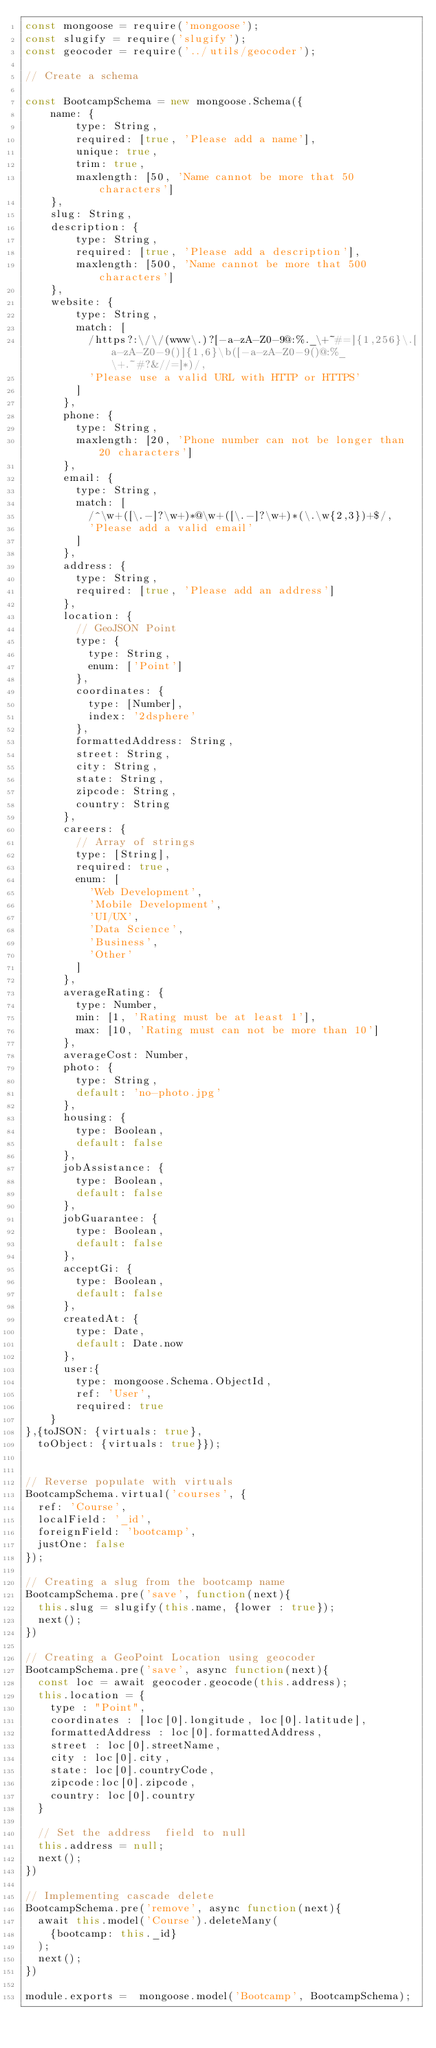<code> <loc_0><loc_0><loc_500><loc_500><_JavaScript_>const mongoose = require('mongoose');
const slugify = require('slugify');
const geocoder = require('../utils/geocoder');

// Create a schema

const BootcampSchema = new mongoose.Schema({
    name: {
        type: String,
        required: [true, 'Please add a name'],
        unique: true,
        trim: true,
        maxlength: [50, 'Name cannot be more that 50 characters']
    },
    slug: String,
    description: {
        type: String,
        required: [true, 'Please add a description'],
        maxlength: [500, 'Name cannot be more that 500 characters']
    },
    website: {
        type: String,
        match: [
          /https?:\/\/(www\.)?[-a-zA-Z0-9@:%._\+~#=]{1,256}\.[a-zA-Z0-9()]{1,6}\b([-a-zA-Z0-9()@:%_\+.~#?&//=]*)/,
          'Please use a valid URL with HTTP or HTTPS'
        ]
      },
      phone: {
        type: String,
        maxlength: [20, 'Phone number can not be longer than 20 characters']
      },
      email: {
        type: String,
        match: [
          /^\w+([\.-]?\w+)*@\w+([\.-]?\w+)*(\.\w{2,3})+$/,
          'Please add a valid email'
        ]
      },
      address: {
        type: String,
        required: [true, 'Please add an address']
      },
      location: {
        // GeoJSON Point
        type: {
          type: String,
          enum: ['Point']
        },
        coordinates: {
          type: [Number],
          index: '2dsphere'
        },
        formattedAddress: String,
        street: String,
        city: String,
        state: String,
        zipcode: String,
        country: String
      },
      careers: {
        // Array of strings
        type: [String],
        required: true,
        enum: [
          'Web Development',
          'Mobile Development',
          'UI/UX',
          'Data Science',
          'Business',
          'Other'
        ]
      },
      averageRating: {
        type: Number,
        min: [1, 'Rating must be at least 1'],
        max: [10, 'Rating must can not be more than 10']
      },
      averageCost: Number,
      photo: {
        type: String,
        default: 'no-photo.jpg'
      },
      housing: {
        type: Boolean,
        default: false
      },
      jobAssistance: {
        type: Boolean,
        default: false
      },
      jobGuarantee: {
        type: Boolean,
        default: false
      },
      acceptGi: {
        type: Boolean,
        default: false
      },
      createdAt: {
        type: Date,
        default: Date.now
      },
      user:{
        type: mongoose.Schema.ObjectId,
        ref: 'User',
        required: true
    }
},{toJSON: {virtuals: true},
  toObject: {virtuals: true}});


// Reverse populate with virtuals
BootcampSchema.virtual('courses', {
  ref: 'Course',
  localField: '_id',
  foreignField: 'bootcamp',
  justOne: false
});

// Creating a slug from the bootcamp name
BootcampSchema.pre('save', function(next){
  this.slug = slugify(this.name, {lower : true});
  next();
})

// Creating a GeoPoint Location using geocoder
BootcampSchema.pre('save', async function(next){
  const loc = await geocoder.geocode(this.address);
  this.location = {
    type : "Point",
    coordinates : [loc[0].longitude, loc[0].latitude],
    formattedAddress : loc[0].formattedAddress,
    street : loc[0].streetName,
    city : loc[0].city,
    state: loc[0].countryCode,
    zipcode:loc[0].zipcode,
    country: loc[0].country
  }

  // Set the address  field to null
  this.address = null;
  next();
})

// Implementing cascade delete
BootcampSchema.pre('remove', async function(next){
  await this.model('Course').deleteMany(
    {bootcamp: this._id}
  );
  next();
})

module.exports =  mongoose.model('Bootcamp', BootcampSchema);</code> 